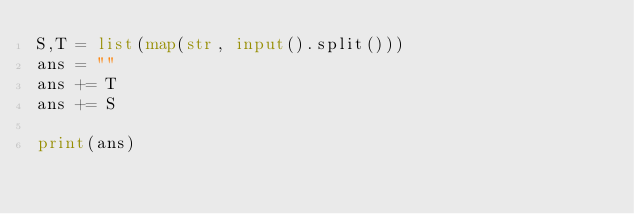<code> <loc_0><loc_0><loc_500><loc_500><_Python_>S,T = list(map(str, input().split()))
ans = ""
ans += T
ans += S

print(ans)</code> 